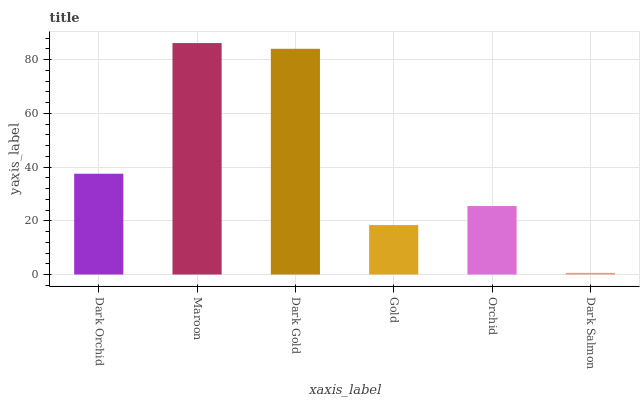Is Dark Salmon the minimum?
Answer yes or no. Yes. Is Maroon the maximum?
Answer yes or no. Yes. Is Dark Gold the minimum?
Answer yes or no. No. Is Dark Gold the maximum?
Answer yes or no. No. Is Maroon greater than Dark Gold?
Answer yes or no. Yes. Is Dark Gold less than Maroon?
Answer yes or no. Yes. Is Dark Gold greater than Maroon?
Answer yes or no. No. Is Maroon less than Dark Gold?
Answer yes or no. No. Is Dark Orchid the high median?
Answer yes or no. Yes. Is Orchid the low median?
Answer yes or no. Yes. Is Dark Salmon the high median?
Answer yes or no. No. Is Maroon the low median?
Answer yes or no. No. 